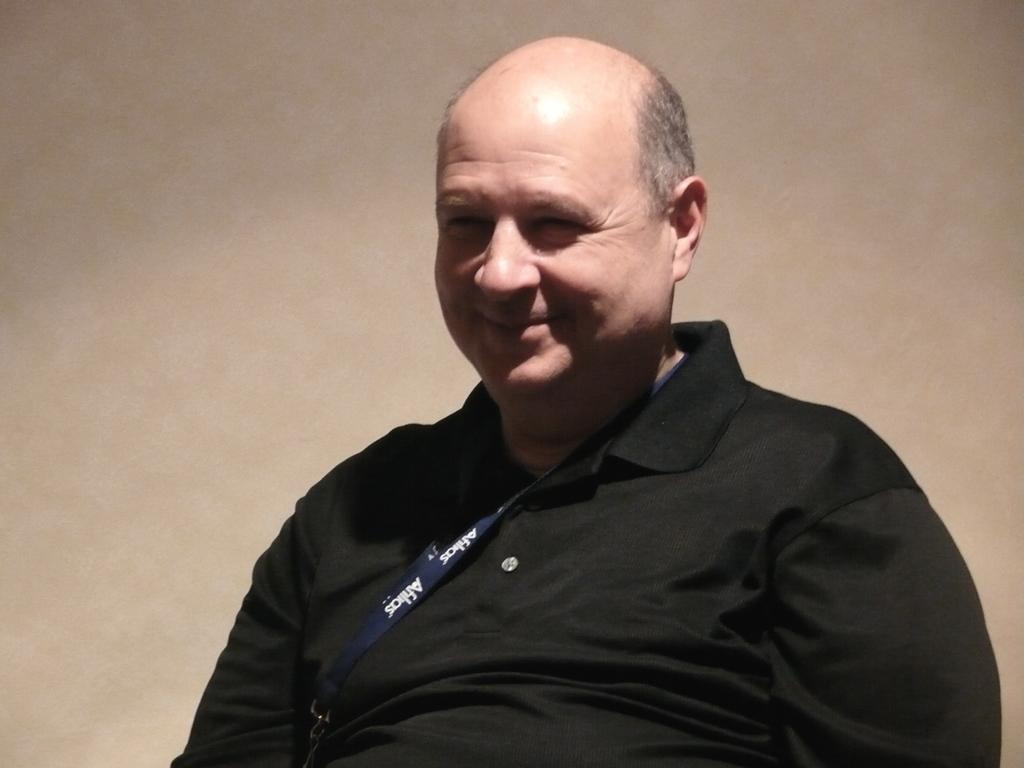Who or what is the main subject in the image? There is a person in the center of the image. What is the person doing or expressing in the image? The person is smiling. What can be seen in the background of the image? There is a wall in the background of the image. Can you see any guns in the image? No, there are no guns present in the image. Is the person giving birth in the image? No, the person is not giving birth in the image; they are simply smiling. 